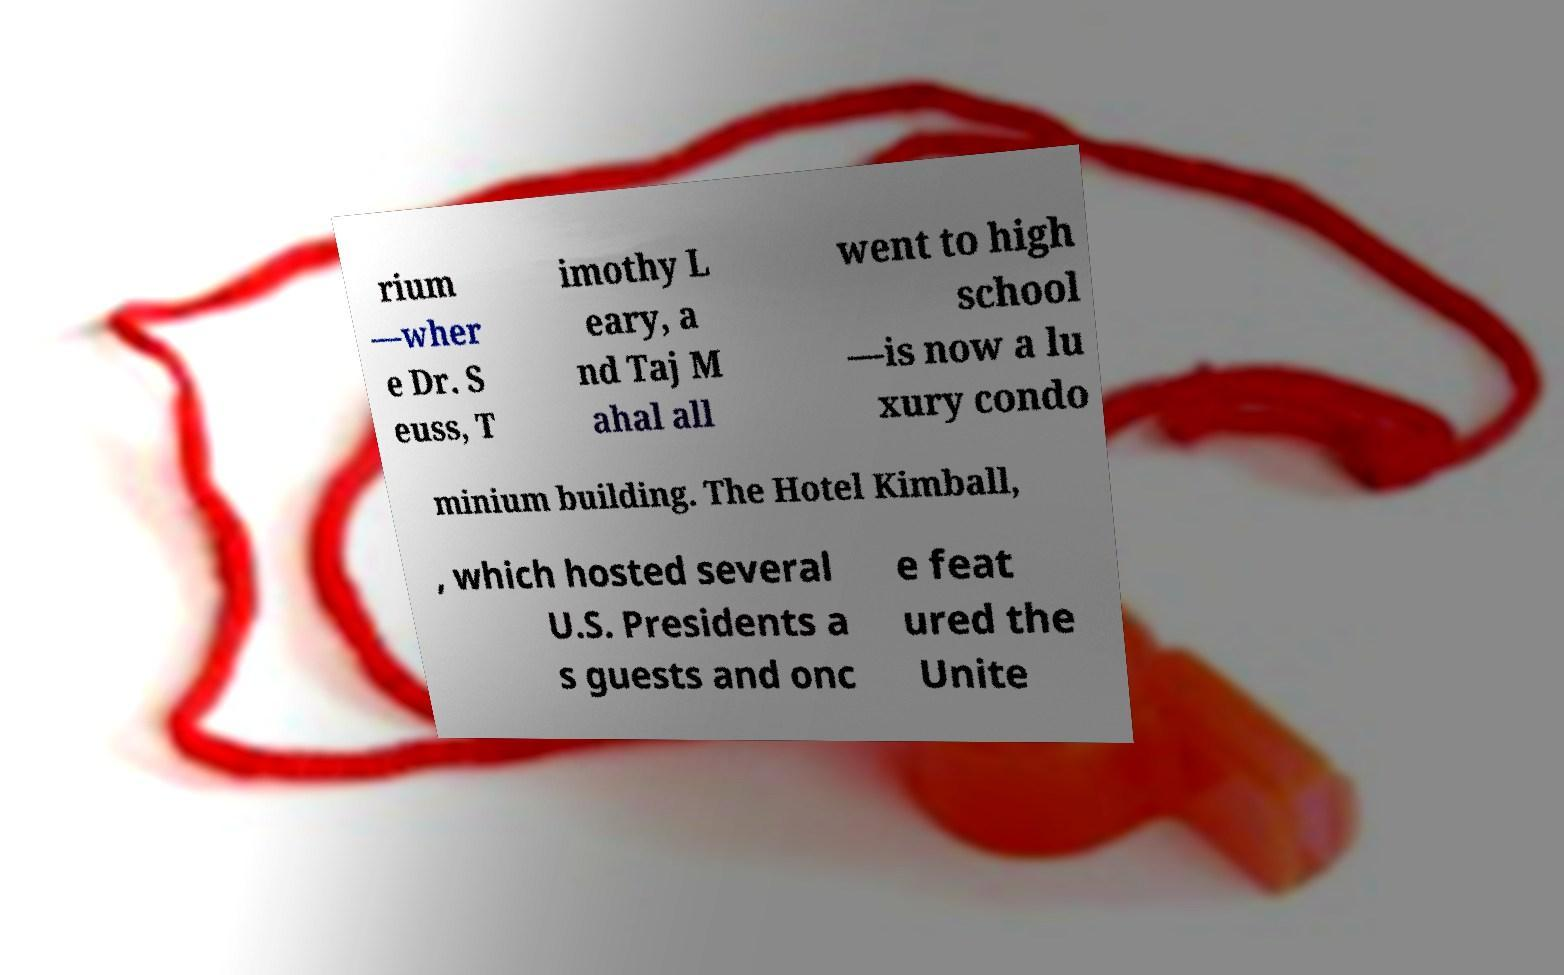Can you accurately transcribe the text from the provided image for me? rium —wher e Dr. S euss, T imothy L eary, a nd Taj M ahal all went to high school —is now a lu xury condo minium building. The Hotel Kimball, , which hosted several U.S. Presidents a s guests and onc e feat ured the Unite 